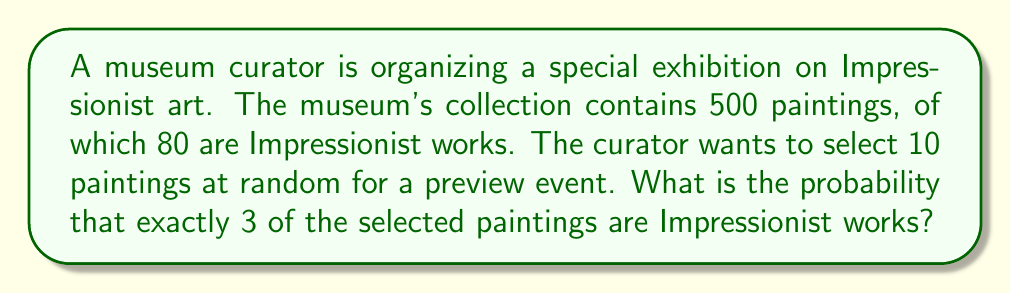Provide a solution to this math problem. To solve this problem, we'll use the hypergeometric distribution, which is appropriate for sampling without replacement from a finite population.

Let's define our variables:
- $N = 500$ (total number of paintings)
- $K = 80$ (number of Impressionist paintings)
- $n = 10$ (number of paintings selected)
- $k = 3$ (number of Impressionist paintings we want in our selection)

The probability mass function for the hypergeometric distribution is:

$$ P(X = k) = \frac{\binom{K}{k} \binom{N-K}{n-k}}{\binom{N}{n}} $$

Where:
- $\binom{K}{k}$ is the number of ways to choose $k$ Impressionist paintings from $K$ total Impressionist paintings
- $\binom{N-K}{n-k}$ is the number of ways to choose the remaining non-Impressionist paintings
- $\binom{N}{n}$ is the total number of ways to choose $n$ paintings from $N$ total paintings

Let's calculate each part:

1. $\binom{K}{k} = \binom{80}{3} = 82,160$
2. $\binom{N-K}{n-k} = \binom{420}{7} = 1,378,815,600$
3. $\binom{N}{n} = \binom{500}{10} = 2,245,940,000$

Now, let's substitute these values into our probability mass function:

$$ P(X = 3) = \frac{82,160 \cdot 1,378,815,600}{2,245,940,000} \approx 0.2522 $$

Therefore, the probability of selecting exactly 3 Impressionist paintings out of 10 randomly chosen paintings is approximately 0.2522 or 25.22%.
Answer: The probability is approximately 0.2522 or 25.22%. 